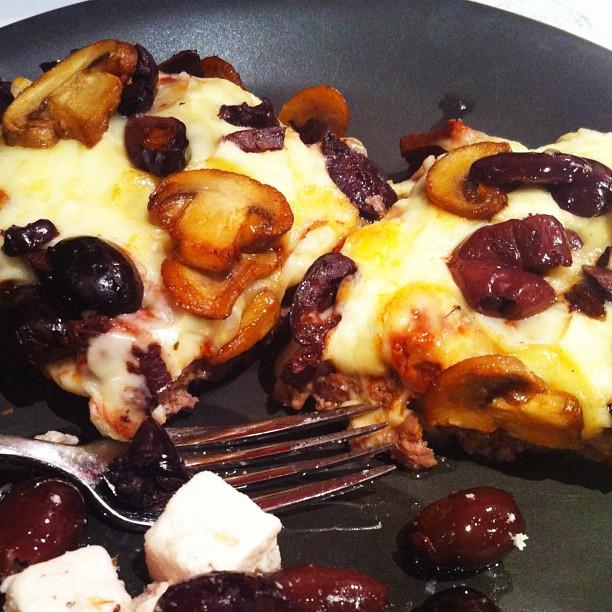What utensil is visible?
Keep it brief. Fork. Has someone taken a bite of this meal?
Short answer required. Yes. Is this a healthy meal?
Concise answer only. No. 